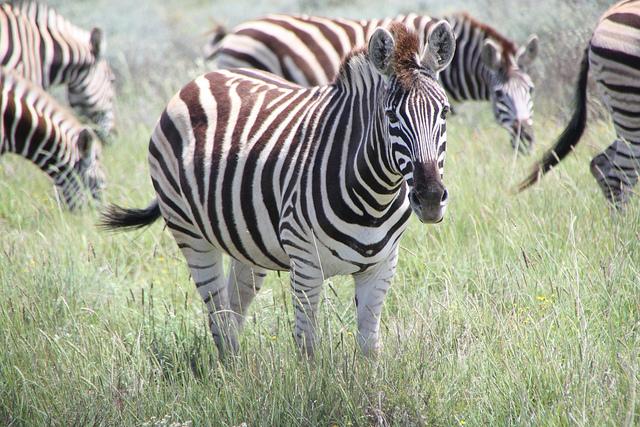Is the photographer physically close to the zebras?
Short answer required. Yes. Is there any sky showing?
Short answer required. No. What color tail do these zebras have?
Concise answer only. Black. How many zebras are there?
Quick response, please. 5. 